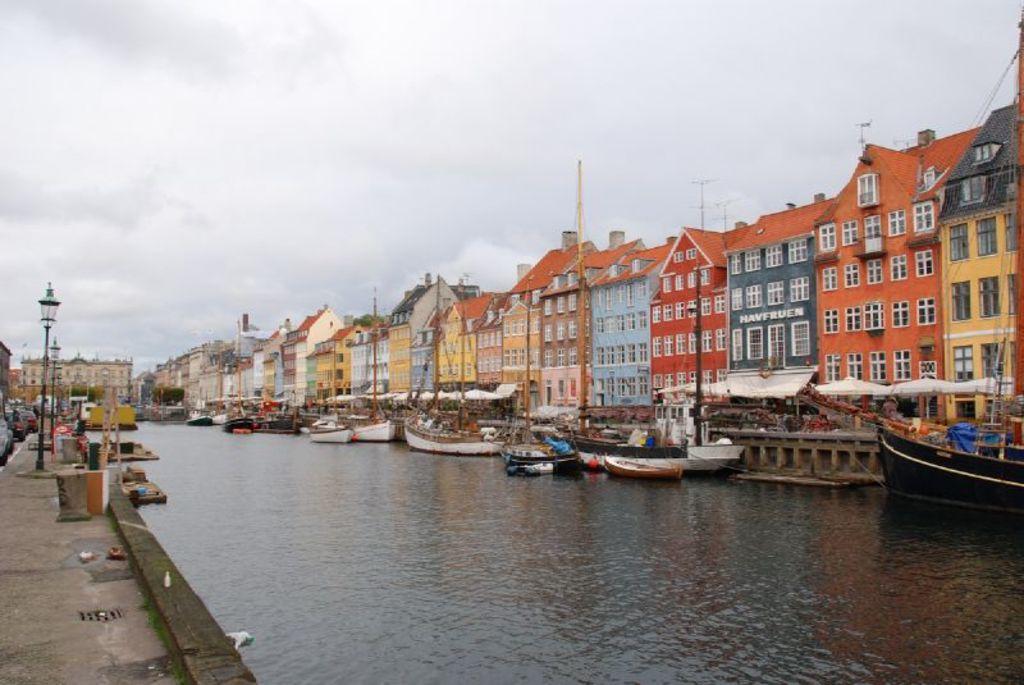In one or two sentences, can you explain what this image depicts? In this picture we can see water at the bottom, there are some boats in the water, we can see buildings on the right side, on the left side we can see poles and lights, there is the sky at the top of the picture. 